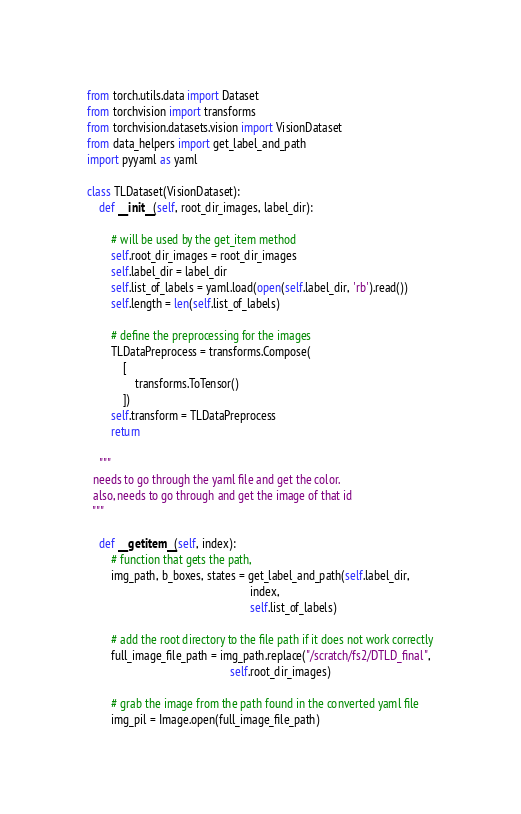<code> <loc_0><loc_0><loc_500><loc_500><_Python_>from torch.utils.data import Dataset
from torchvision import transforms
from torchvision.datasets.vision import VisionDataset
from data_helpers import get_label_and_path
import pyyaml as yaml

class TLDataset(VisionDataset):
    def __init__(self, root_dir_images, label_dir):

        # will be used by the get_item method
        self.root_dir_images = root_dir_images
        self.label_dir = label_dir
        self.list_of_labels = yaml.load(open(self.label_dir, 'rb').read())
        self.length = len(self.list_of_labels)

        # define the preprocessing for the images
        TLDataPreprocess = transforms.Compose(
            [
                transforms.ToTensor()
            ])
        self.transform = TLDataPreprocess
        return

    """
  needs to go through the yaml file and get the color.
  also, needs to go through and get the image of that id
  """

    def __getitem__(self, index):
        # function that gets the path,
        img_path, b_boxes, states = get_label_and_path(self.label_dir,
                                                       index,
                                                       self.list_of_labels)

        # add the root directory to the file path if it does not work correctly
        full_image_file_path = img_path.replace("/scratch/fs2/DTLD_final",
                                                self.root_dir_images)

        # grab the image from the path found in the converted yaml file
        img_pil = Image.open(full_image_file_path)</code> 